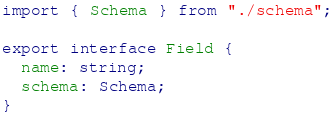Convert code to text. <code><loc_0><loc_0><loc_500><loc_500><_TypeScript_>import { Schema } from "./schema";

export interface Field {
  name: string;
  schema: Schema;
}
</code> 